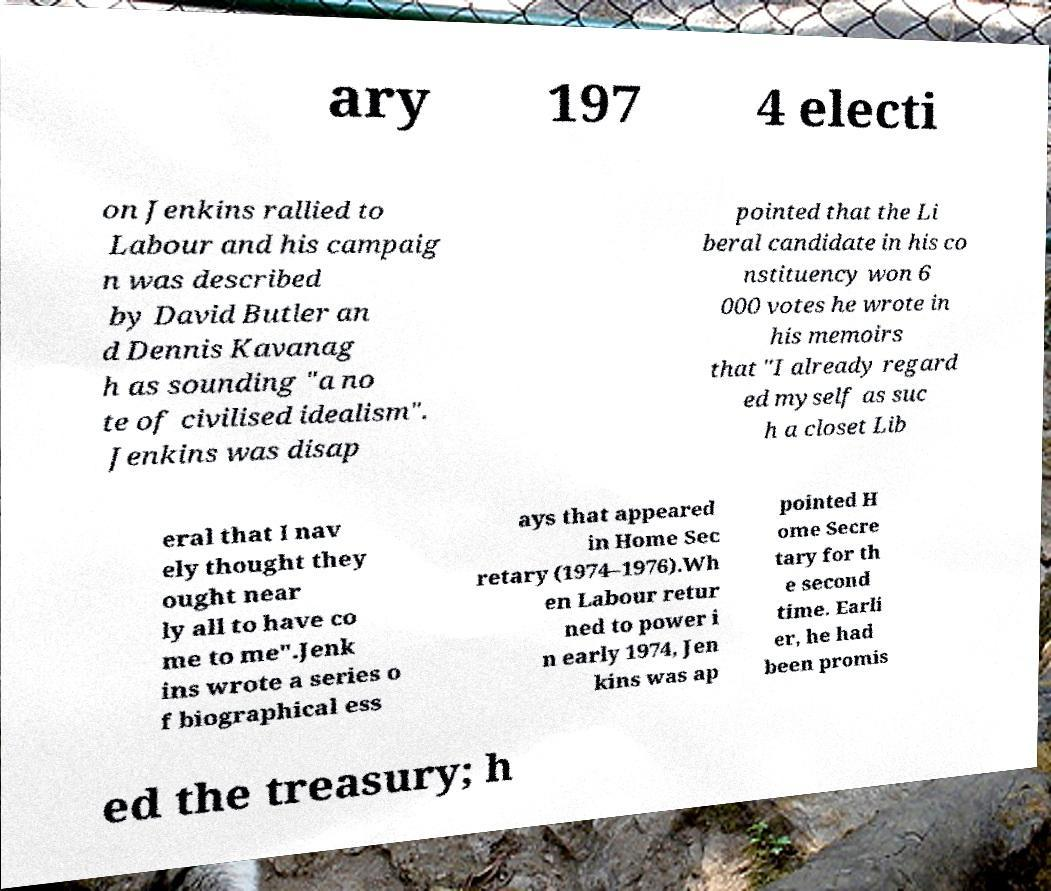Could you assist in decoding the text presented in this image and type it out clearly? ary 197 4 electi on Jenkins rallied to Labour and his campaig n was described by David Butler an d Dennis Kavanag h as sounding "a no te of civilised idealism". Jenkins was disap pointed that the Li beral candidate in his co nstituency won 6 000 votes he wrote in his memoirs that "I already regard ed myself as suc h a closet Lib eral that I nav ely thought they ought near ly all to have co me to me".Jenk ins wrote a series o f biographical ess ays that appeared in Home Sec retary (1974–1976).Wh en Labour retur ned to power i n early 1974, Jen kins was ap pointed H ome Secre tary for th e second time. Earli er, he had been promis ed the treasury; h 